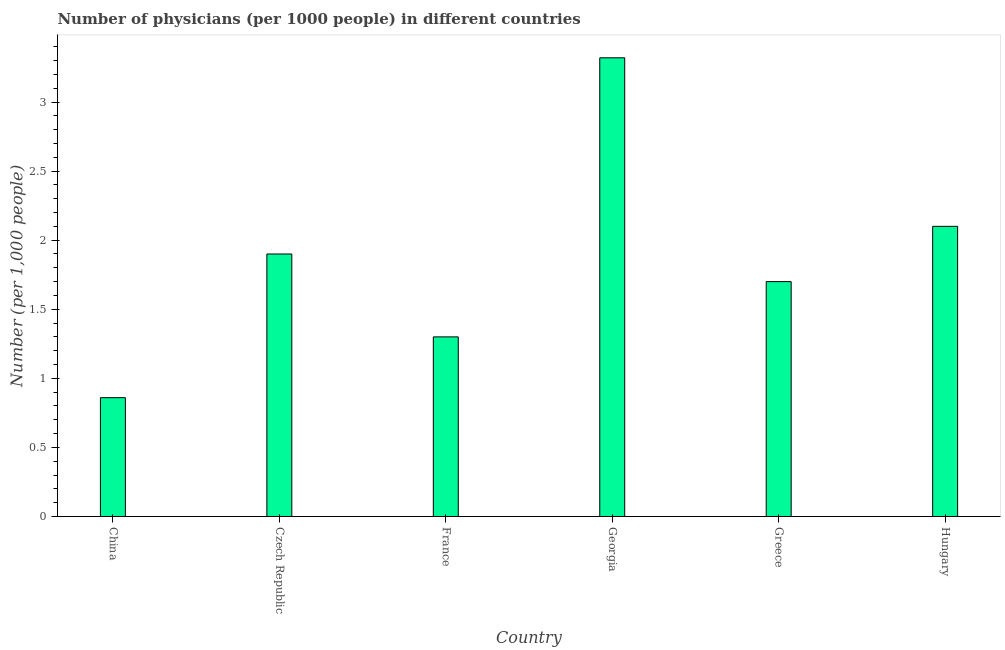What is the title of the graph?
Your answer should be very brief. Number of physicians (per 1000 people) in different countries. What is the label or title of the Y-axis?
Offer a very short reply. Number (per 1,0 people). What is the number of physicians in Greece?
Keep it short and to the point. 1.7. Across all countries, what is the maximum number of physicians?
Provide a succinct answer. 3.32. Across all countries, what is the minimum number of physicians?
Your answer should be compact. 0.86. In which country was the number of physicians maximum?
Give a very brief answer. Georgia. What is the sum of the number of physicians?
Make the answer very short. 11.18. What is the difference between the number of physicians in Greece and Hungary?
Provide a short and direct response. -0.4. What is the average number of physicians per country?
Your response must be concise. 1.86. What is the median number of physicians?
Make the answer very short. 1.8. In how many countries, is the number of physicians greater than 1 ?
Your answer should be very brief. 5. What is the ratio of the number of physicians in China to that in Greece?
Provide a short and direct response. 0.51. What is the difference between the highest and the second highest number of physicians?
Offer a terse response. 1.22. Is the sum of the number of physicians in France and Greece greater than the maximum number of physicians across all countries?
Your response must be concise. No. What is the difference between the highest and the lowest number of physicians?
Give a very brief answer. 2.46. In how many countries, is the number of physicians greater than the average number of physicians taken over all countries?
Keep it short and to the point. 3. How many bars are there?
Keep it short and to the point. 6. What is the Number (per 1,000 people) in China?
Your answer should be compact. 0.86. What is the Number (per 1,000 people) of France?
Offer a terse response. 1.3. What is the Number (per 1,000 people) of Georgia?
Your answer should be compact. 3.32. What is the Number (per 1,000 people) of Greece?
Offer a very short reply. 1.7. What is the difference between the Number (per 1,000 people) in China and Czech Republic?
Keep it short and to the point. -1.04. What is the difference between the Number (per 1,000 people) in China and France?
Your answer should be very brief. -0.44. What is the difference between the Number (per 1,000 people) in China and Georgia?
Your answer should be compact. -2.46. What is the difference between the Number (per 1,000 people) in China and Greece?
Make the answer very short. -0.84. What is the difference between the Number (per 1,000 people) in China and Hungary?
Provide a short and direct response. -1.24. What is the difference between the Number (per 1,000 people) in Czech Republic and France?
Make the answer very short. 0.6. What is the difference between the Number (per 1,000 people) in Czech Republic and Georgia?
Your answer should be compact. -1.42. What is the difference between the Number (per 1,000 people) in France and Georgia?
Offer a very short reply. -2.02. What is the difference between the Number (per 1,000 people) in France and Hungary?
Provide a succinct answer. -0.8. What is the difference between the Number (per 1,000 people) in Georgia and Greece?
Offer a very short reply. 1.62. What is the difference between the Number (per 1,000 people) in Georgia and Hungary?
Provide a short and direct response. 1.22. What is the ratio of the Number (per 1,000 people) in China to that in Czech Republic?
Provide a succinct answer. 0.45. What is the ratio of the Number (per 1,000 people) in China to that in France?
Offer a terse response. 0.66. What is the ratio of the Number (per 1,000 people) in China to that in Georgia?
Keep it short and to the point. 0.26. What is the ratio of the Number (per 1,000 people) in China to that in Greece?
Offer a terse response. 0.51. What is the ratio of the Number (per 1,000 people) in China to that in Hungary?
Your answer should be compact. 0.41. What is the ratio of the Number (per 1,000 people) in Czech Republic to that in France?
Give a very brief answer. 1.46. What is the ratio of the Number (per 1,000 people) in Czech Republic to that in Georgia?
Provide a short and direct response. 0.57. What is the ratio of the Number (per 1,000 people) in Czech Republic to that in Greece?
Offer a very short reply. 1.12. What is the ratio of the Number (per 1,000 people) in Czech Republic to that in Hungary?
Make the answer very short. 0.91. What is the ratio of the Number (per 1,000 people) in France to that in Georgia?
Ensure brevity in your answer.  0.39. What is the ratio of the Number (per 1,000 people) in France to that in Greece?
Ensure brevity in your answer.  0.77. What is the ratio of the Number (per 1,000 people) in France to that in Hungary?
Your answer should be very brief. 0.62. What is the ratio of the Number (per 1,000 people) in Georgia to that in Greece?
Offer a terse response. 1.95. What is the ratio of the Number (per 1,000 people) in Georgia to that in Hungary?
Your answer should be compact. 1.58. What is the ratio of the Number (per 1,000 people) in Greece to that in Hungary?
Your answer should be compact. 0.81. 